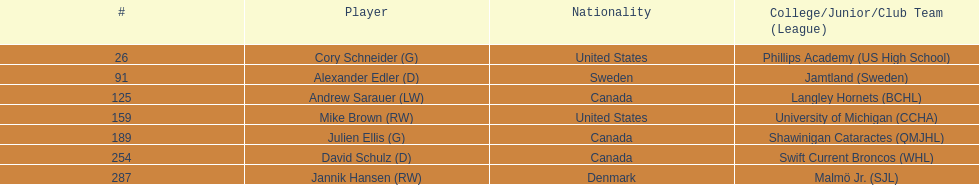How many players were from the united states? 2. 